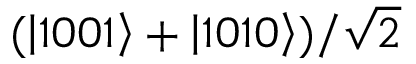Convert formula to latex. <formula><loc_0><loc_0><loc_500><loc_500>( \left | 1 0 0 1 \right > + \left | 1 0 1 0 \right > ) / \sqrt { 2 }</formula> 